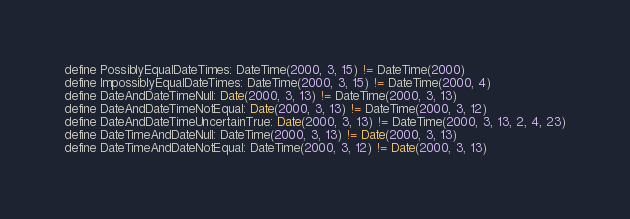Convert code to text. <code><loc_0><loc_0><loc_500><loc_500><_SQL_>define PossiblyEqualDateTimes: DateTime(2000, 3, 15) != DateTime(2000)
define ImpossiblyEqualDateTimes: DateTime(2000, 3, 15) != DateTime(2000, 4)
define DateAndDateTimeNull: Date(2000, 3, 13) != DateTime(2000, 3, 13)
define DateAndDateTimeNotEqual: Date(2000, 3, 13) != DateTime(2000, 3, 12)
define DateAndDateTimeUncertainTrue: Date(2000, 3, 13) != DateTime(2000, 3, 13, 2, 4, 23)
define DateTimeAndDateNull: DateTime(2000, 3, 13) != Date(2000, 3, 13)
define DateTimeAndDateNotEqual: DateTime(2000, 3, 12) != Date(2000, 3, 13)</code> 